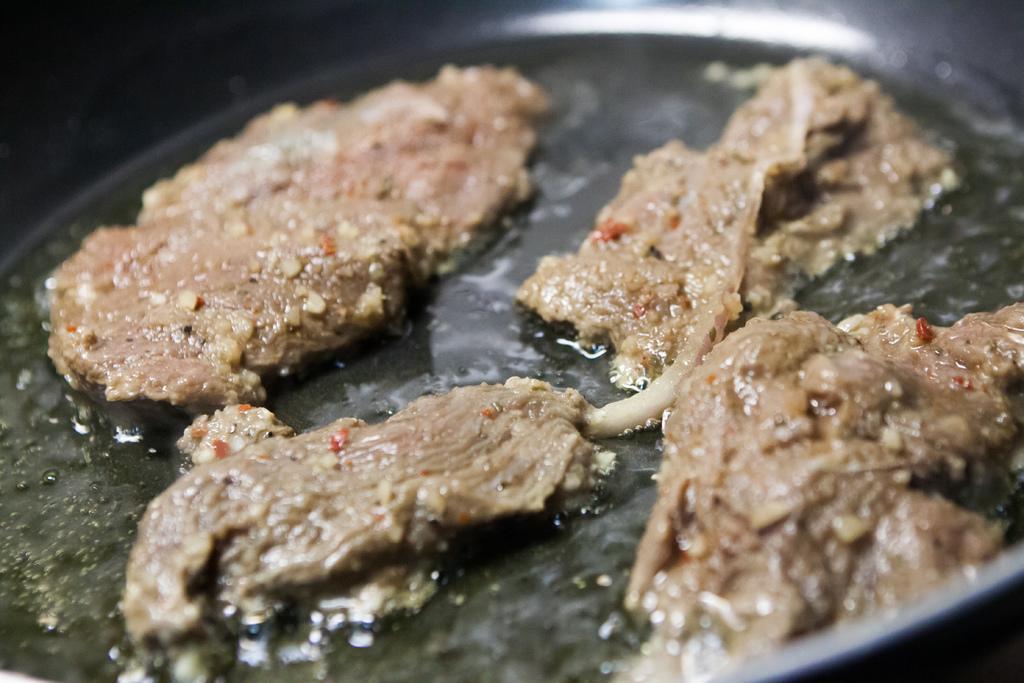Could you give a brief overview of what you see in this image? This image consists of food which is in the pan. 